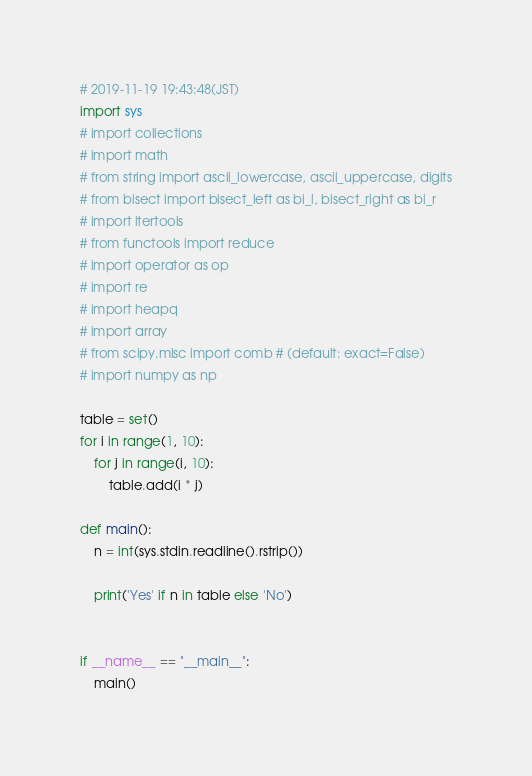Convert code to text. <code><loc_0><loc_0><loc_500><loc_500><_Python_># 2019-11-19 19:43:48(JST)
import sys
# import collections
# import math
# from string import ascii_lowercase, ascii_uppercase, digits
# from bisect import bisect_left as bi_l, bisect_right as bi_r
# import itertools
# from functools import reduce
# import operator as op
# import re
# import heapq
# import array
# from scipy.misc import comb # (default: exact=False)
# import numpy as np 

table = set()
for i in range(1, 10):
    for j in range(i, 10):
        table.add(i * j)

def main():
    n = int(sys.stdin.readline().rstrip())
    
    print('Yes' if n in table else 'No')


if __name__ == "__main__":
    main()
</code> 